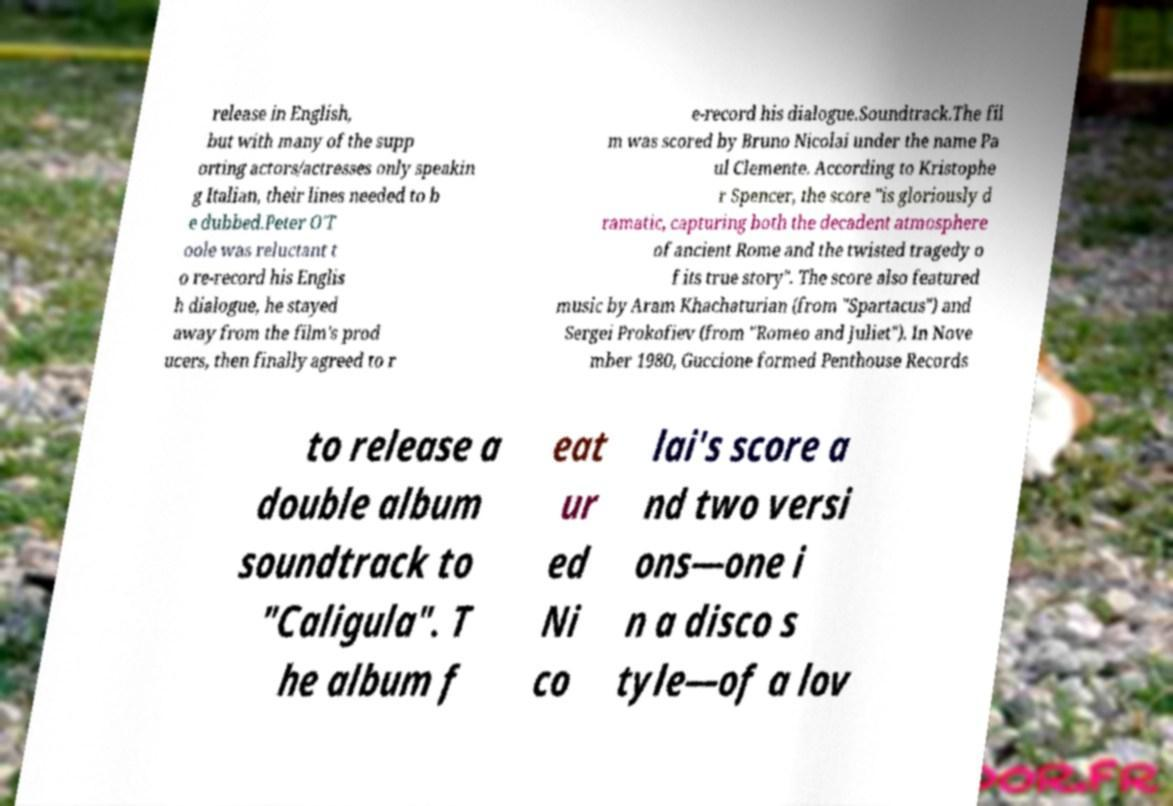Can you accurately transcribe the text from the provided image for me? release in English, but with many of the supp orting actors/actresses only speakin g Italian, their lines needed to b e dubbed.Peter O'T oole was reluctant t o re-record his Englis h dialogue, he stayed away from the film's prod ucers, then finally agreed to r e-record his dialogue.Soundtrack.The fil m was scored by Bruno Nicolai under the name Pa ul Clemente. According to Kristophe r Spencer, the score "is gloriously d ramatic, capturing both the decadent atmosphere of ancient Rome and the twisted tragedy o f its true story". The score also featured music by Aram Khachaturian (from "Spartacus") and Sergei Prokofiev (from "Romeo and Juliet"). In Nove mber 1980, Guccione formed Penthouse Records to release a double album soundtrack to "Caligula". T he album f eat ur ed Ni co lai's score a nd two versi ons—one i n a disco s tyle—of a lov 